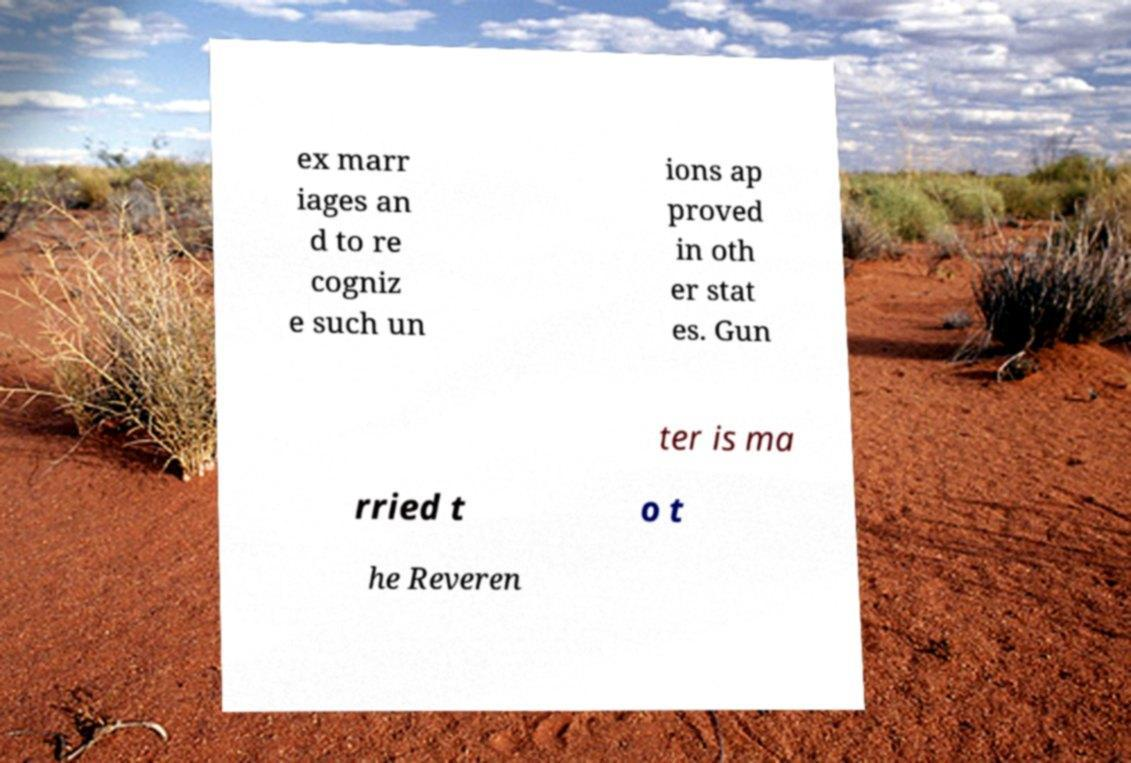Please identify and transcribe the text found in this image. ex marr iages an d to re cogniz e such un ions ap proved in oth er stat es. Gun ter is ma rried t o t he Reveren 